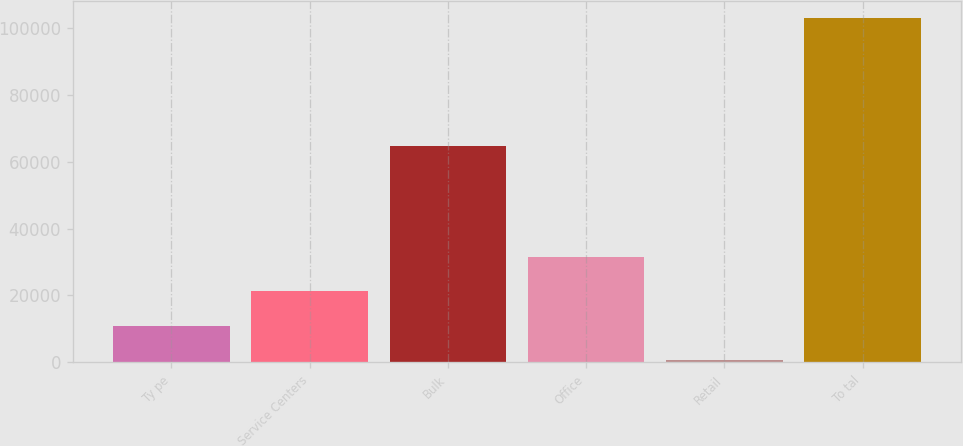Convert chart to OTSL. <chart><loc_0><loc_0><loc_500><loc_500><bar_chart><fcel>Ty pe<fcel>Service Centers<fcel>Bulk<fcel>Office<fcel>Retail<fcel>To tal<nl><fcel>10959.7<fcel>21174.4<fcel>64786<fcel>31389.1<fcel>745<fcel>102892<nl></chart> 